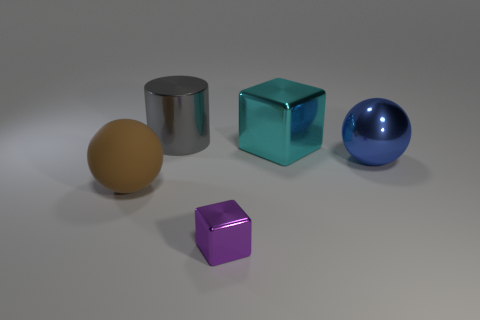Add 4 big metallic cylinders. How many objects exist? 9 Subtract all spheres. How many objects are left? 3 Subtract 1 spheres. How many spheres are left? 1 Subtract all yellow balls. Subtract all gray cylinders. How many balls are left? 2 Subtract all red blocks. How many blue spheres are left? 1 Subtract all green rubber things. Subtract all big matte spheres. How many objects are left? 4 Add 1 shiny things. How many shiny things are left? 5 Add 1 matte blocks. How many matte blocks exist? 1 Subtract 1 blue balls. How many objects are left? 4 